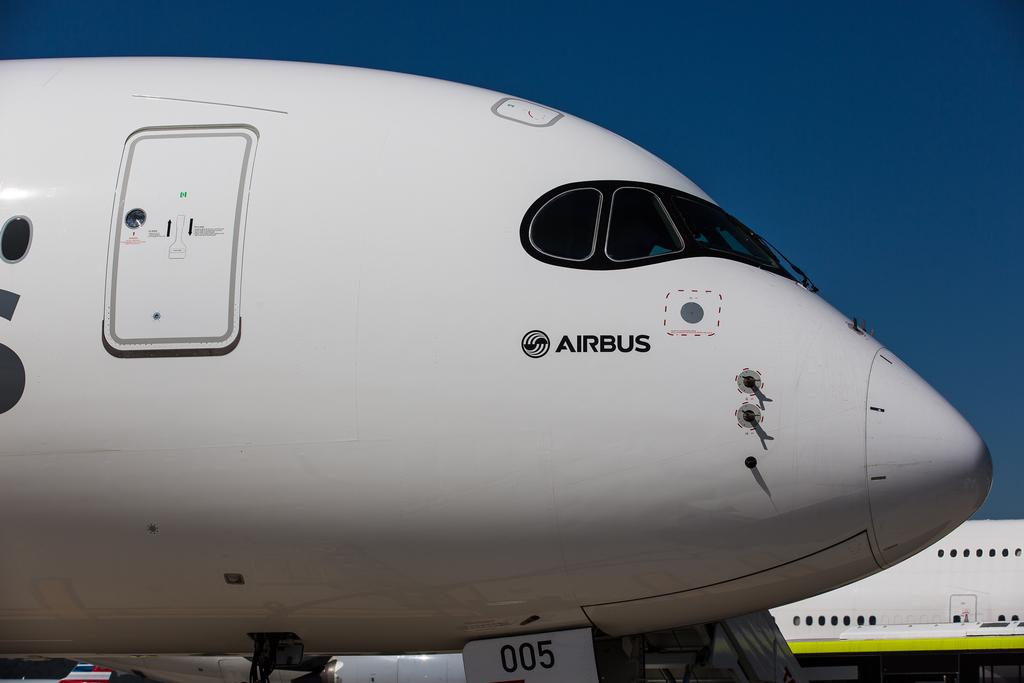What is the main subject of the image? The main subject of the image is airplanes. How are the airplanes depicted in the image? The airplanes appear to be truncated. What can be seen in the background of the image? There is sky visible in the background of the image. What type of corn is growing in the image? There is no corn present in the image; it features airplanes and a sky background. Can you tell me how many lettuce leaves are visible in the image? There is no lettuce present in the image; it features airplanes and a sky background. 